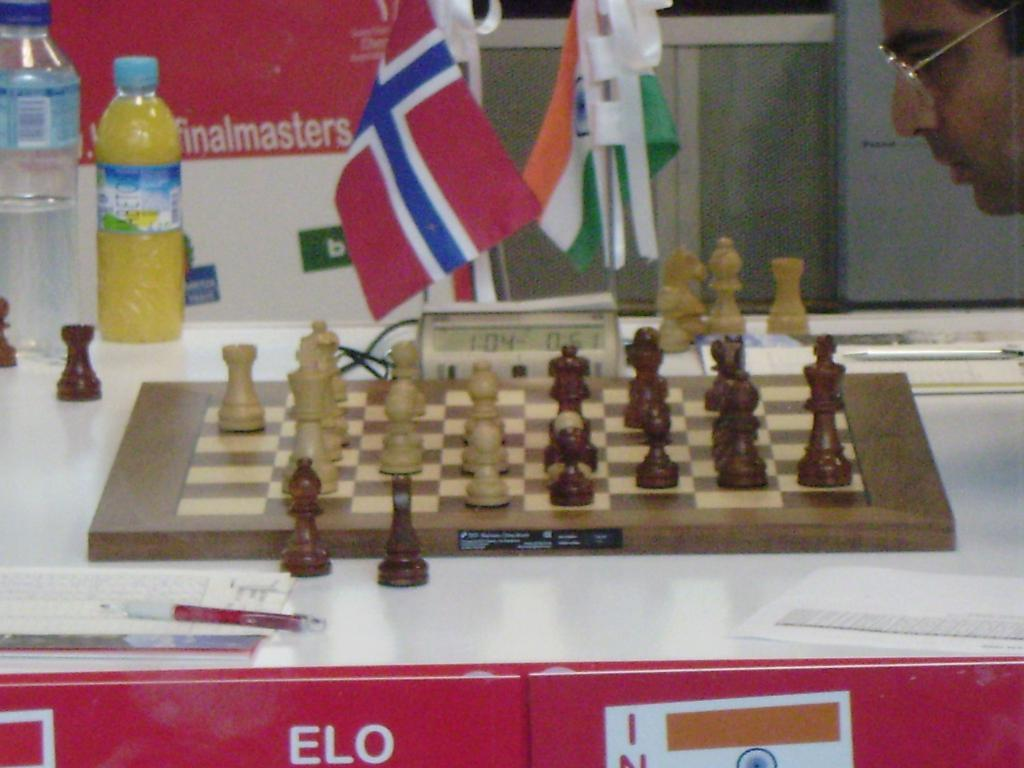<image>
Render a clear and concise summary of the photo. A brown and beige chess board with the ELO logo on the red table side. 